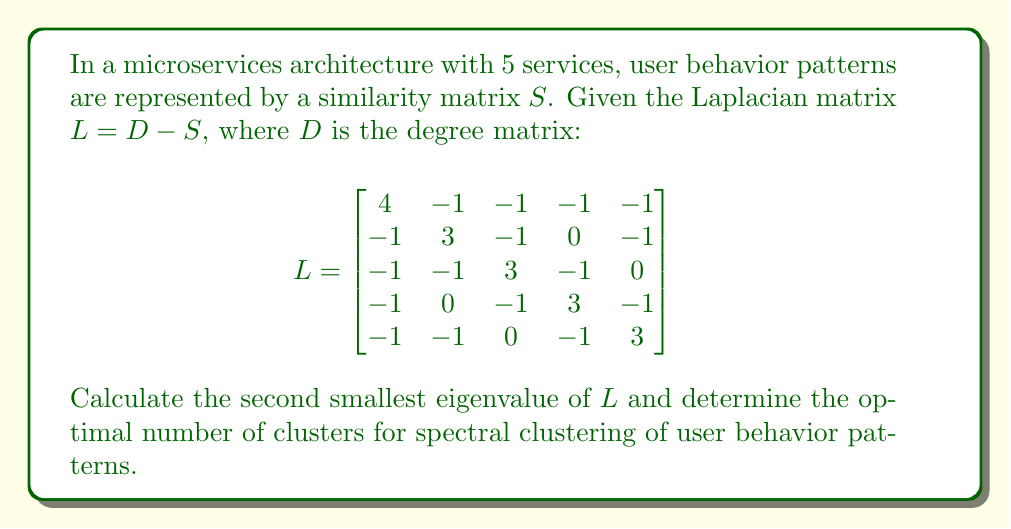Show me your answer to this math problem. To solve this problem, we'll follow these steps:

1) First, we need to find the eigenvalues of the Laplacian matrix $L$. The characteristic equation is:

   $\det(L - \lambda I) = 0$

2) Expanding this determinant, we get the polynomial:

   $\lambda^5 - 16\lambda^4 + 90\lambda^3 - 220\lambda^2 + 225\lambda = 0$

3) Factoring this polynomial:

   $\lambda(\lambda - 1)(\lambda - 3)(\lambda - 5)(\lambda - 7) = 0$

4) The eigenvalues are therefore: $\lambda_1 = 0, \lambda_2 = 1, \lambda_3 = 3, \lambda_4 = 5, \lambda_5 = 7$

5) The second smallest eigenvalue is $\lambda_2 = 1$.

6) In spectral clustering, the number of clusters is often determined by looking for a "gap" in the eigenvalue spectrum. The optimal number of clusters is typically chosen where this gap is largest.

7) The differences between consecutive eigenvalues are:
   $1 - 0 = 1$
   $3 - 1 = 2$
   $5 - 3 = 2$
   $7 - 5 = 2$

8) The largest gap is between $\lambda_2$ and $\lambda_3$, suggesting that the optimal number of clusters is 2.

This result indicates that the user behavior patterns in this microservices architecture can be effectively grouped into 2 distinct clusters.
Answer: $\lambda_2 = 1$; Optimal number of clusters: 2 